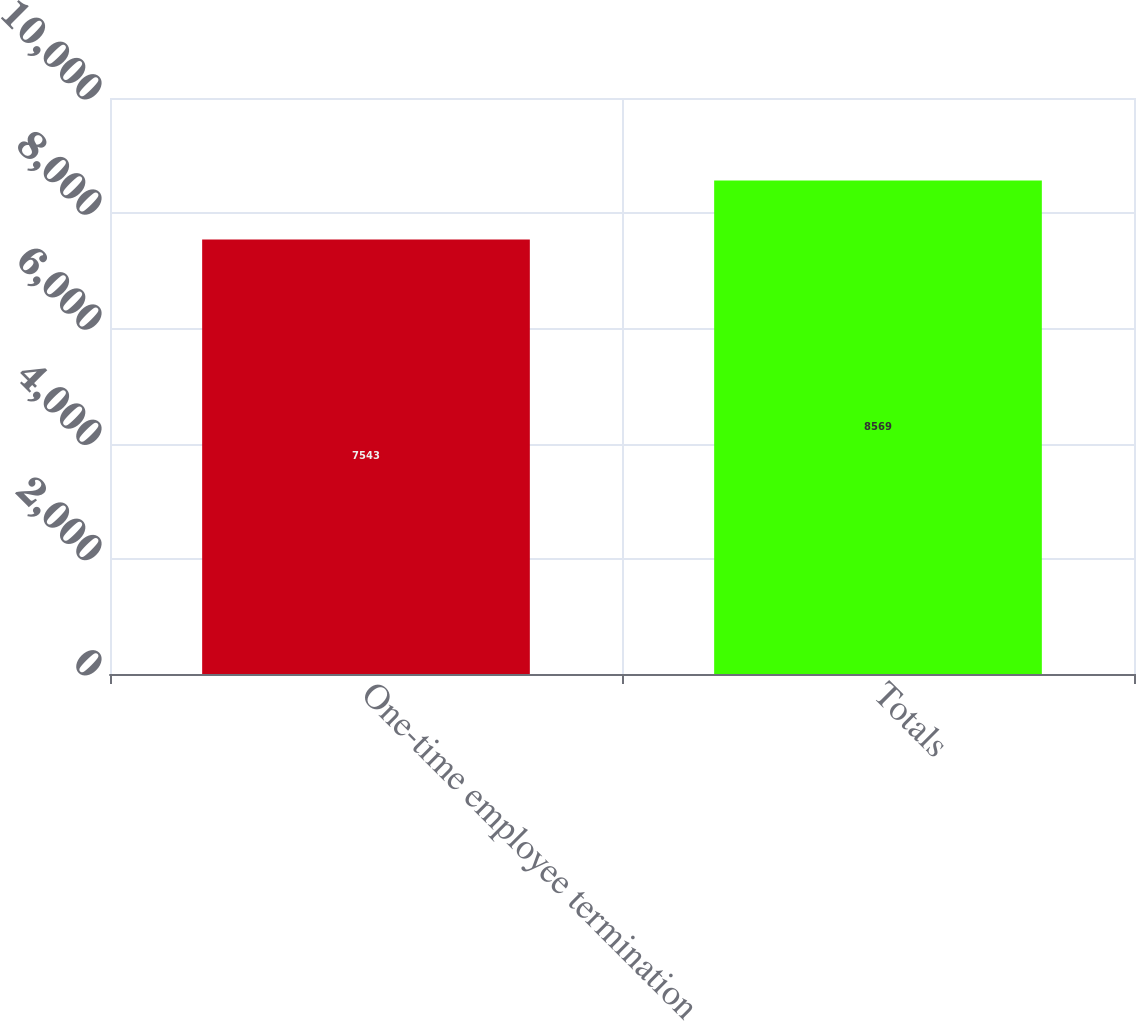Convert chart to OTSL. <chart><loc_0><loc_0><loc_500><loc_500><bar_chart><fcel>One-time employee termination<fcel>Totals<nl><fcel>7543<fcel>8569<nl></chart> 